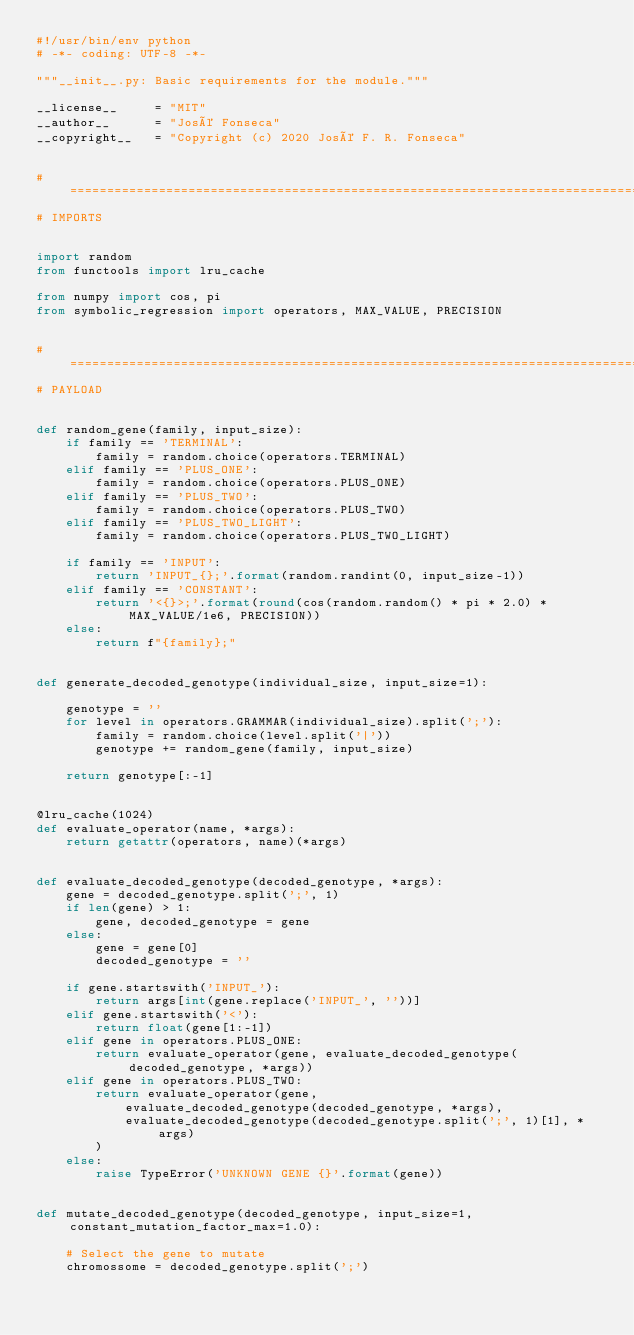<code> <loc_0><loc_0><loc_500><loc_500><_Python_>#!/usr/bin/env python
# -*- coding: UTF-8 -*-

"""__init__.py: Basic requirements for the module."""

__license__     = "MIT"
__author__      = "José Fonseca"
__copyright__   = "Copyright (c) 2020 José F. R. Fonseca"


# ======================================================================================================================
# IMPORTS


import random
from functools import lru_cache

from numpy import cos, pi
from symbolic_regression import operators, MAX_VALUE, PRECISION


# ======================================================================================================================
# PAYLOAD


def random_gene(family, input_size):
    if family == 'TERMINAL':
        family = random.choice(operators.TERMINAL)
    elif family == 'PLUS_ONE':
        family = random.choice(operators.PLUS_ONE)
    elif family == 'PLUS_TWO':
        family = random.choice(operators.PLUS_TWO)
    elif family == 'PLUS_TWO_LIGHT':
        family = random.choice(operators.PLUS_TWO_LIGHT)

    if family == 'INPUT':
        return 'INPUT_{};'.format(random.randint(0, input_size-1))
    elif family == 'CONSTANT':
        return '<{}>;'.format(round(cos(random.random() * pi * 2.0) * MAX_VALUE/1e6, PRECISION))
    else:
        return f"{family};"


def generate_decoded_genotype(individual_size, input_size=1):

    genotype = ''
    for level in operators.GRAMMAR(individual_size).split(';'):
        family = random.choice(level.split('|'))
        genotype += random_gene(family, input_size)

    return genotype[:-1]


@lru_cache(1024)
def evaluate_operator(name, *args):
    return getattr(operators, name)(*args)


def evaluate_decoded_genotype(decoded_genotype, *args):
    gene = decoded_genotype.split(';', 1)
    if len(gene) > 1:
        gene, decoded_genotype = gene
    else:
        gene = gene[0]
        decoded_genotype = ''

    if gene.startswith('INPUT_'):
        return args[int(gene.replace('INPUT_', ''))]
    elif gene.startswith('<'):
        return float(gene[1:-1])
    elif gene in operators.PLUS_ONE:
        return evaluate_operator(gene, evaluate_decoded_genotype(decoded_genotype, *args))
    elif gene in operators.PLUS_TWO:
        return evaluate_operator(gene,
            evaluate_decoded_genotype(decoded_genotype, *args),
            evaluate_decoded_genotype(decoded_genotype.split(';', 1)[1], *args)
        )
    else:
        raise TypeError('UNKNOWN GENE {}'.format(gene))


def mutate_decoded_genotype(decoded_genotype, input_size=1, constant_mutation_factor_max=1.0):

    # Select the gene to mutate
    chromossome = decoded_genotype.split(';')</code> 